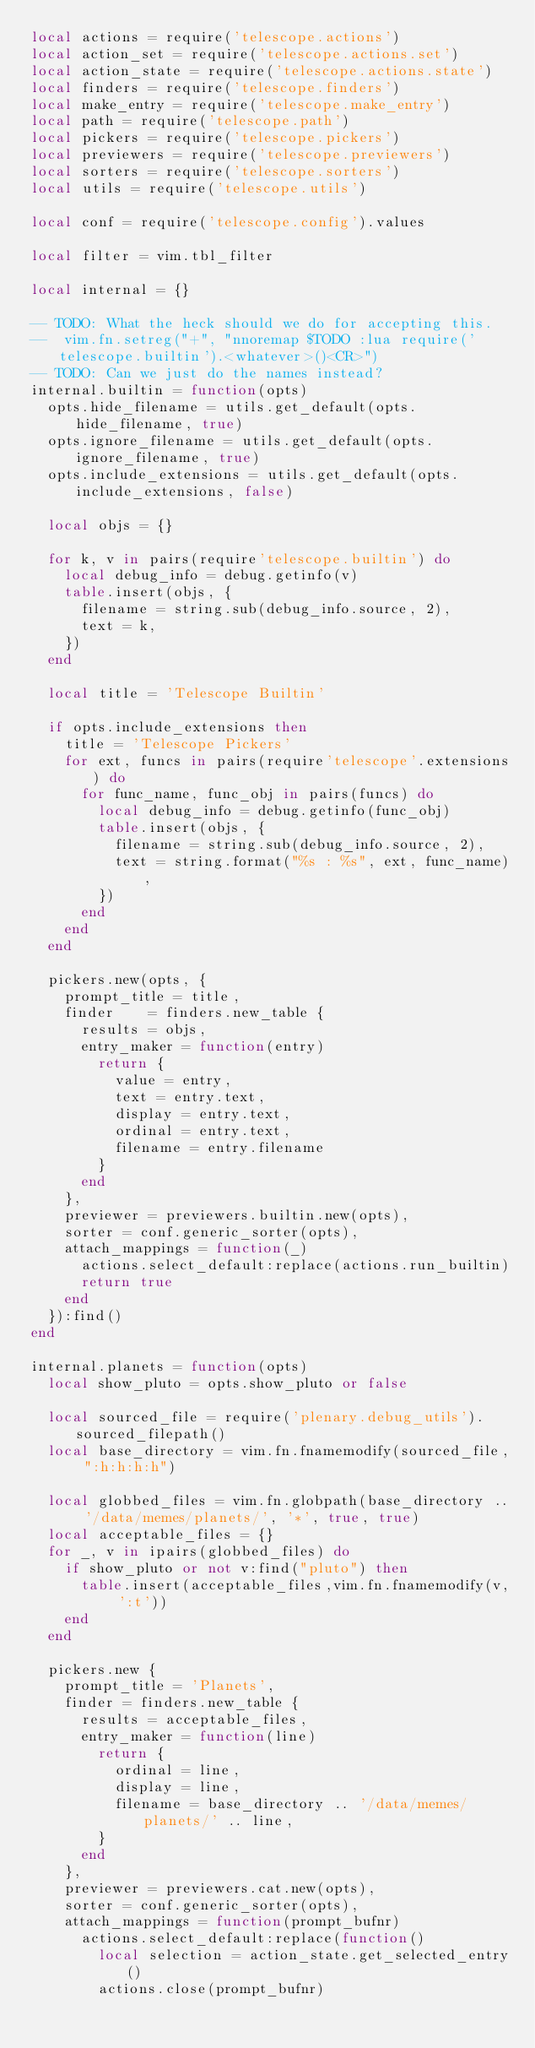<code> <loc_0><loc_0><loc_500><loc_500><_Lua_>local actions = require('telescope.actions')
local action_set = require('telescope.actions.set')
local action_state = require('telescope.actions.state')
local finders = require('telescope.finders')
local make_entry = require('telescope.make_entry')
local path = require('telescope.path')
local pickers = require('telescope.pickers')
local previewers = require('telescope.previewers')
local sorters = require('telescope.sorters')
local utils = require('telescope.utils')

local conf = require('telescope.config').values

local filter = vim.tbl_filter

local internal = {}

-- TODO: What the heck should we do for accepting this.
--  vim.fn.setreg("+", "nnoremap $TODO :lua require('telescope.builtin').<whatever>()<CR>")
-- TODO: Can we just do the names instead?
internal.builtin = function(opts)
  opts.hide_filename = utils.get_default(opts.hide_filename, true)
  opts.ignore_filename = utils.get_default(opts.ignore_filename, true)
  opts.include_extensions = utils.get_default(opts.include_extensions, false)

  local objs = {}

  for k, v in pairs(require'telescope.builtin') do
    local debug_info = debug.getinfo(v)
    table.insert(objs, {
      filename = string.sub(debug_info.source, 2),
      text = k,
    })
  end

  local title = 'Telescope Builtin'

  if opts.include_extensions then
    title = 'Telescope Pickers'
    for ext, funcs in pairs(require'telescope'.extensions) do
      for func_name, func_obj in pairs(funcs) do
        local debug_info = debug.getinfo(func_obj)
        table.insert(objs, {
          filename = string.sub(debug_info.source, 2),
          text = string.format("%s : %s", ext, func_name),
        })
      end
    end
  end

  pickers.new(opts, {
    prompt_title = title,
    finder    = finders.new_table {
      results = objs,
      entry_maker = function(entry)
        return {
          value = entry,
          text = entry.text,
          display = entry.text,
          ordinal = entry.text,
          filename = entry.filename
        }
      end
    },
    previewer = previewers.builtin.new(opts),
    sorter = conf.generic_sorter(opts),
    attach_mappings = function(_)
      actions.select_default:replace(actions.run_builtin)
      return true
    end
  }):find()
end

internal.planets = function(opts)
  local show_pluto = opts.show_pluto or false

  local sourced_file = require('plenary.debug_utils').sourced_filepath()
  local base_directory = vim.fn.fnamemodify(sourced_file, ":h:h:h:h")

  local globbed_files = vim.fn.globpath(base_directory .. '/data/memes/planets/', '*', true, true)
  local acceptable_files = {}
  for _, v in ipairs(globbed_files) do
    if show_pluto or not v:find("pluto") then
      table.insert(acceptable_files,vim.fn.fnamemodify(v, ':t'))
    end
  end

  pickers.new {
    prompt_title = 'Planets',
    finder = finders.new_table {
      results = acceptable_files,
      entry_maker = function(line)
        return {
          ordinal = line,
          display = line,
          filename = base_directory .. '/data/memes/planets/' .. line,
        }
      end
    },
    previewer = previewers.cat.new(opts),
    sorter = conf.generic_sorter(opts),
    attach_mappings = function(prompt_bufnr)
      actions.select_default:replace(function()
        local selection = action_state.get_selected_entry()
        actions.close(prompt_bufnr)
</code> 